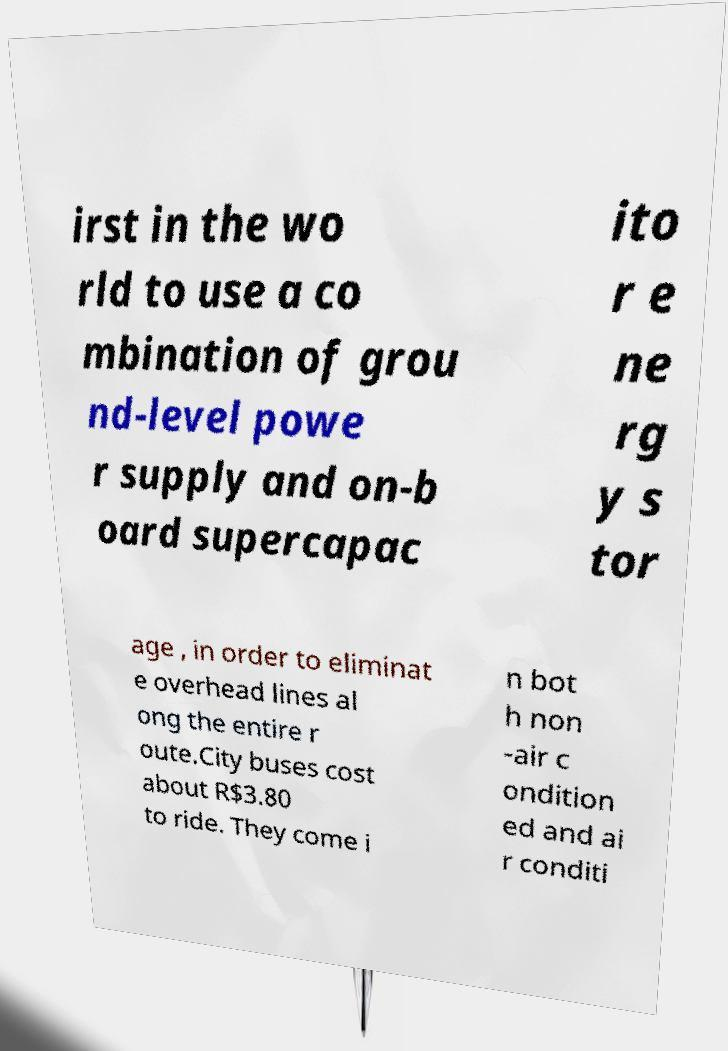There's text embedded in this image that I need extracted. Can you transcribe it verbatim? irst in the wo rld to use a co mbination of grou nd-level powe r supply and on-b oard supercapac ito r e ne rg y s tor age , in order to eliminat e overhead lines al ong the entire r oute.City buses cost about R$3.80 to ride. They come i n bot h non -air c ondition ed and ai r conditi 